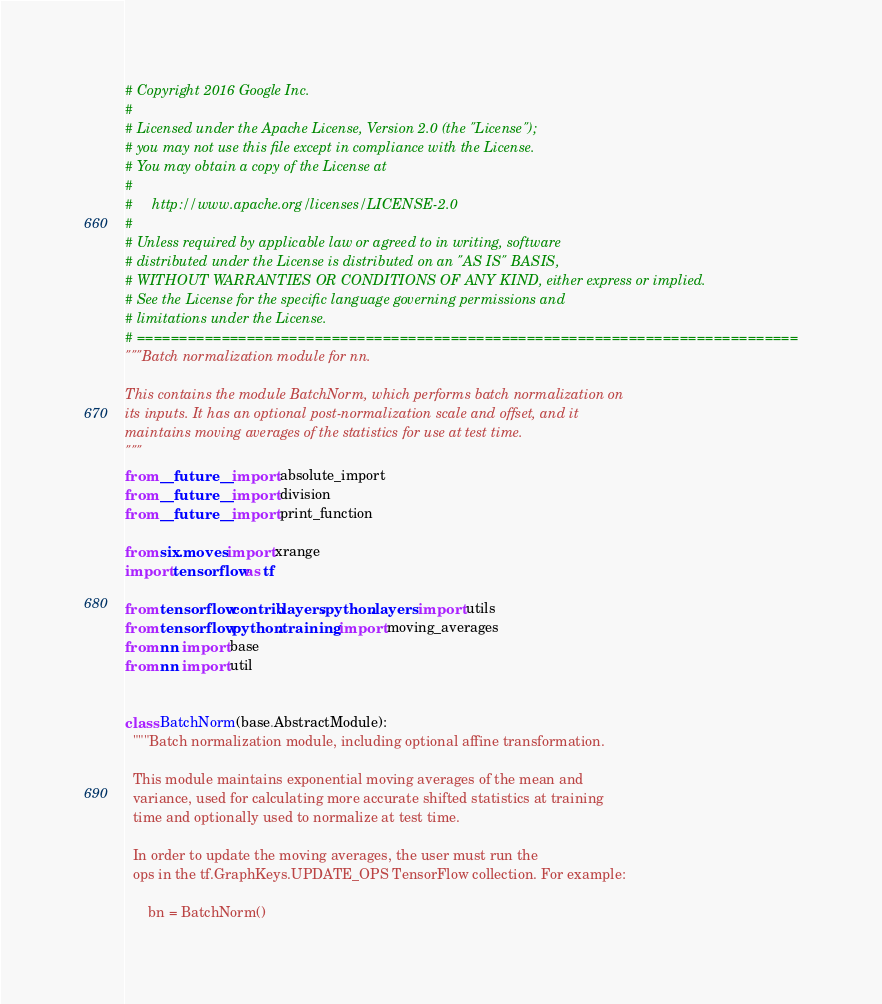Convert code to text. <code><loc_0><loc_0><loc_500><loc_500><_Python_># Copyright 2016 Google Inc.
#
# Licensed under the Apache License, Version 2.0 (the "License");
# you may not use this file except in compliance with the License.
# You may obtain a copy of the License at
#
#     http://www.apache.org/licenses/LICENSE-2.0
#
# Unless required by applicable law or agreed to in writing, software
# distributed under the License is distributed on an "AS IS" BASIS,
# WITHOUT WARRANTIES OR CONDITIONS OF ANY KIND, either express or implied.
# See the License for the specific language governing permissions and
# limitations under the License.
# ==============================================================================
"""Batch normalization module for nn.

This contains the module BatchNorm, which performs batch normalization on
its inputs. It has an optional post-normalization scale and offset, and it
maintains moving averages of the statistics for use at test time.
"""
from __future__ import absolute_import
from __future__ import division
from __future__ import print_function

from six.moves import xrange
import tensorflow as tf

from tensorflow.contrib.layers.python.layers import utils
from tensorflow.python.training import moving_averages
from nn import base
from nn import util


class BatchNorm(base.AbstractModule):
  """Batch normalization module, including optional affine transformation.

  This module maintains exponential moving averages of the mean and
  variance, used for calculating more accurate shifted statistics at training
  time and optionally used to normalize at test time.

  In order to update the moving averages, the user must run the
  ops in the tf.GraphKeys.UPDATE_OPS TensorFlow collection. For example:

      bn = BatchNorm()</code> 